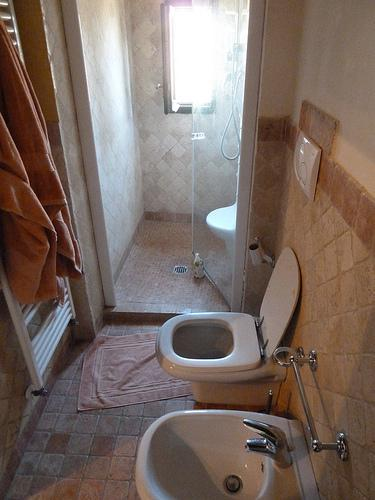Question: where is the towel hanging?
Choices:
A. On a towel rack.
B. On a hook.
C. On the door.
D. On the cabinet.
Answer with the letter. Answer: A Question: why is there a towel on the floor?
Choices:
A. Someone dropped it there.
B. It fell.
C. To keep the floor dry.
D. To sop up water.
Answer with the letter. Answer: C Question: what is on the floor and walls?
Choices:
A. Tiles.
B. Flowers.
C. Paint.
D. Carpet.
Answer with the letter. Answer: A Question: what is coming in through the window?
Choices:
A. Dust.
B. Light.
C. Rain.
D. Wind.
Answer with the letter. Answer: B 